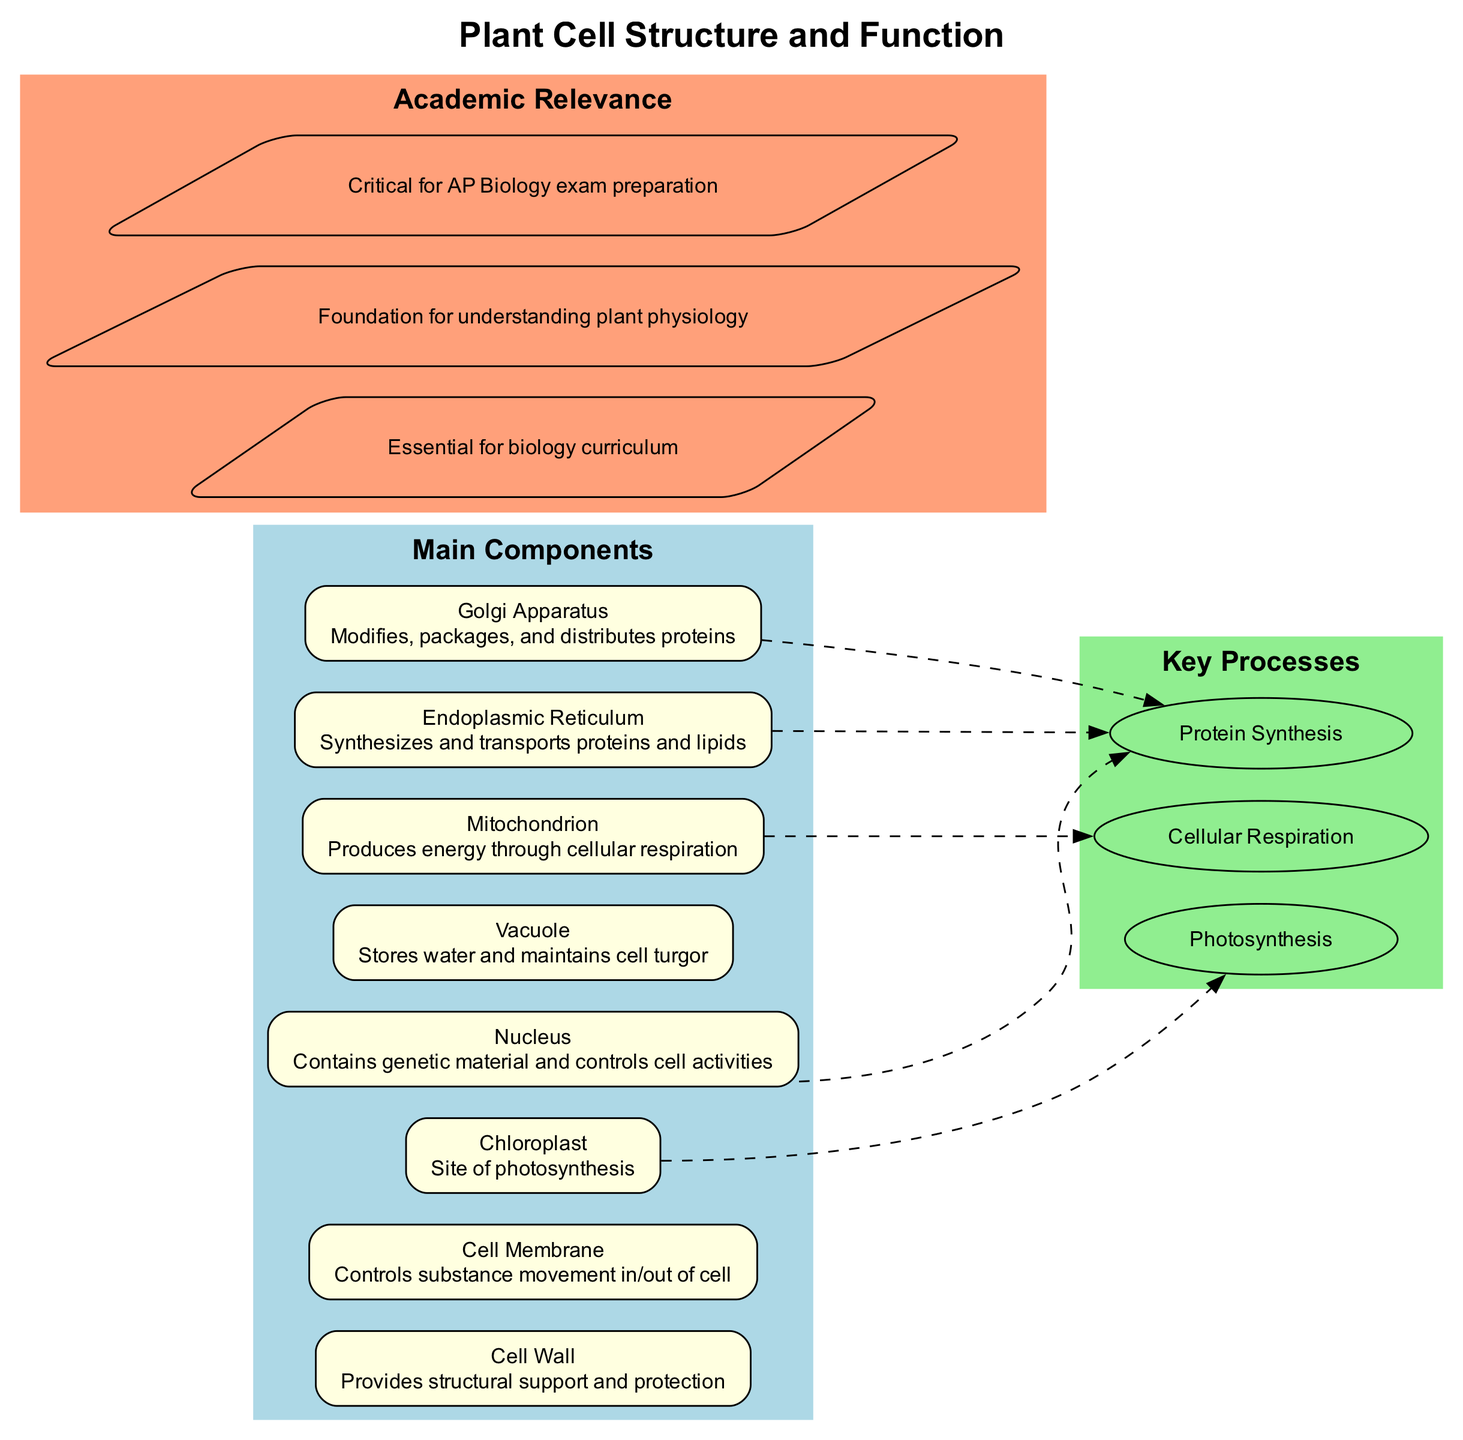What organelle is responsible for photosynthesis? The diagram shows that the chloroplast is labeled as the site of photosynthesis, providing a clear connection between the organelle and this specific function.
Answer: Chloroplast How many main components are labeled in the diagram? By counting each individual component listed in the 'Main Components' section of the diagram, we find there are a total of eight components.
Answer: 8 What is the function of the vacuole? The diagram shows the vacuole, stating that its function is to store water and maintain cell turgor. This directly provides the information needed.
Answer: Stores water and maintains cell turgor Which organelle is involved in energy production? According to the diagram, the mitochondrion is responsible for producing energy through cellular respiration, indicating its direct involvement in energy production.
Answer: Mitochondrion How many key processes are identified in the diagram? The 'Key Processes' section lists a total of three processes: photosynthesis, cellular respiration, and protein synthesis, which can be counted.
Answer: 3 Which organelle controls cell activities? The label of the nucleus specifies its role in containing genetic material and controlling cell activities, clearly indicating which organelle performs this function.
Answer: Nucleus What is the function of the Golgi apparatus? The diagram explains that the Golgi apparatus modifies, packages, and distributes proteins, which directly describes its function.
Answer: Modifies, packages, and distributes proteins Which processes are connected to the nucleus? The diagram shows the nucleus connected specifically to the protein synthesis process, highlighting the relationship between the two.
Answer: Protein Synthesis What color is used to represent the 'Main Components' in the diagram? The color for 'Main Components' is labeled as light blue in the subgraph section of the diagram, specifying the color coding used.
Answer: Light blue 